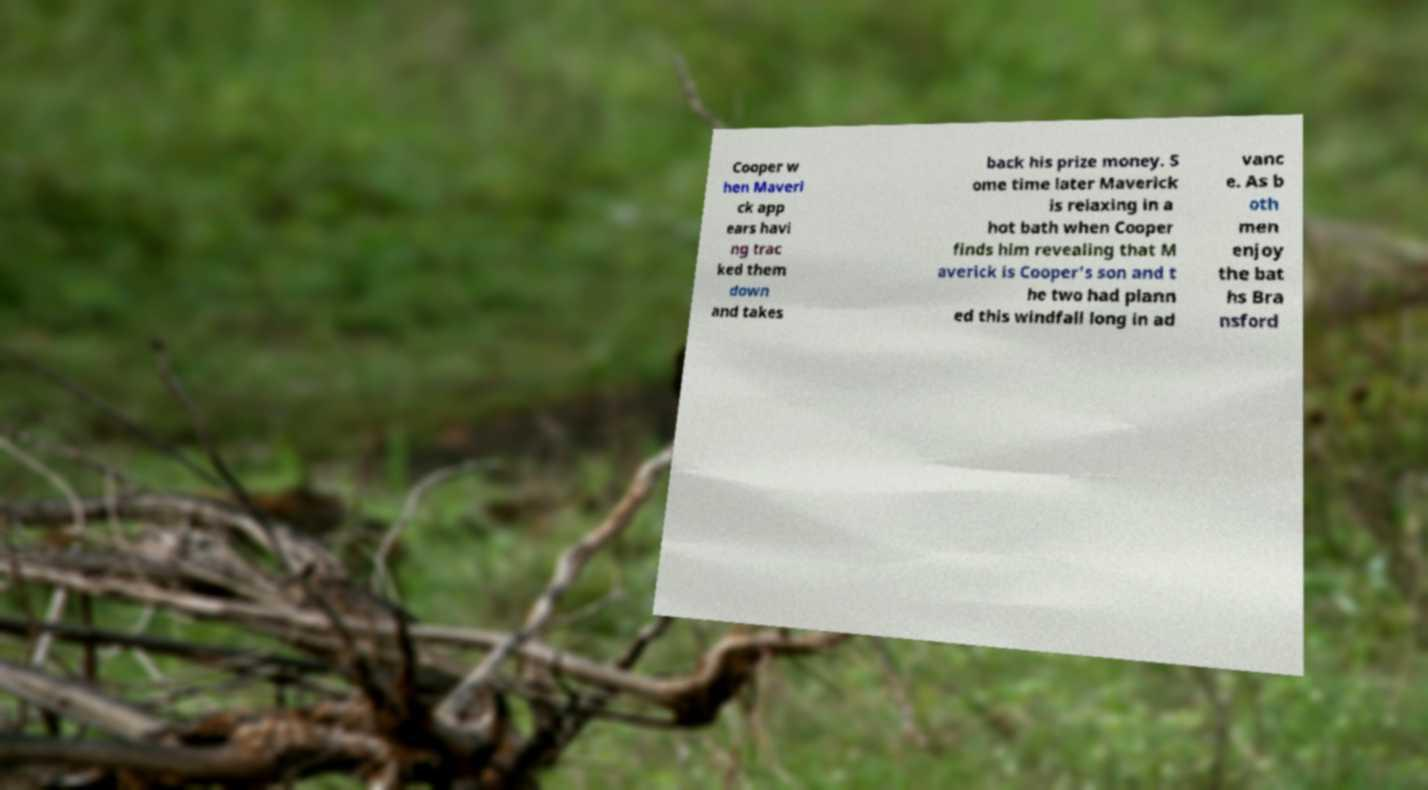There's text embedded in this image that I need extracted. Can you transcribe it verbatim? Cooper w hen Maveri ck app ears havi ng trac ked them down and takes back his prize money. S ome time later Maverick is relaxing in a hot bath when Cooper finds him revealing that M averick is Cooper's son and t he two had plann ed this windfall long in ad vanc e. As b oth men enjoy the bat hs Bra nsford 